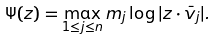Convert formula to latex. <formula><loc_0><loc_0><loc_500><loc_500>\Psi ( z ) = \max _ { 1 \leq j \leq n } m _ { j } \log | z \cdot \bar { v } _ { j } | .</formula> 